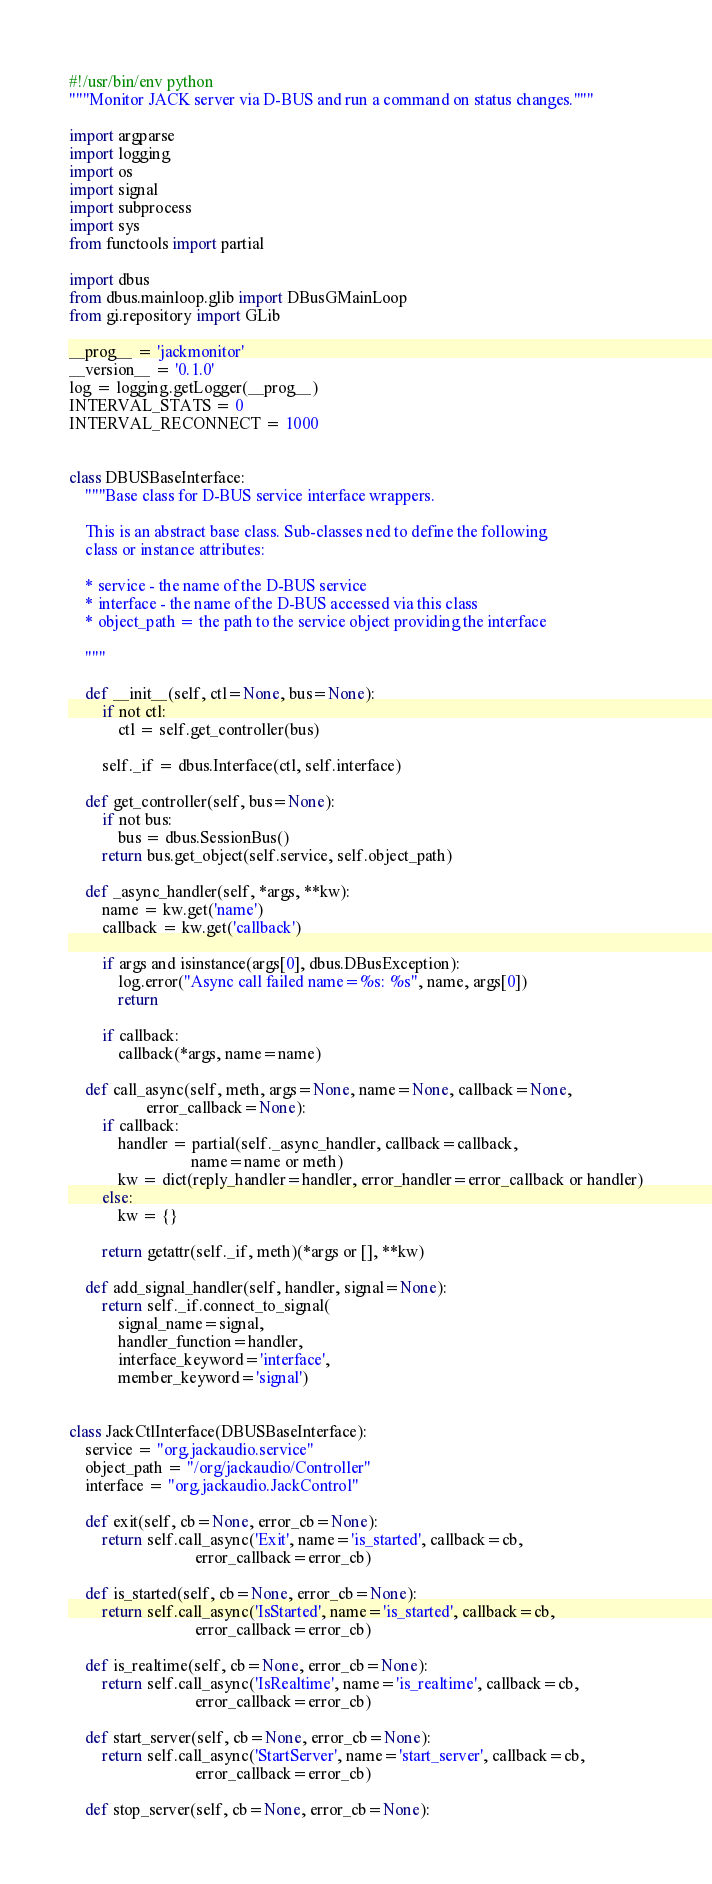<code> <loc_0><loc_0><loc_500><loc_500><_Python_>#!/usr/bin/env python
"""Monitor JACK server via D-BUS and run a command on status changes."""

import argparse
import logging
import os
import signal
import subprocess
import sys
from functools import partial

import dbus
from dbus.mainloop.glib import DBusGMainLoop
from gi.repository import GLib

__prog__ = 'jackmonitor'
__version__ = '0.1.0'
log = logging.getLogger(__prog__)
INTERVAL_STATS = 0
INTERVAL_RECONNECT = 1000


class DBUSBaseInterface:
    """Base class for D-BUS service interface wrappers.

    This is an abstract base class. Sub-classes ned to define the following
    class or instance attributes:

    * service - the name of the D-BUS service
    * interface - the name of the D-BUS accessed via this class
    * object_path = the path to the service object providing the interface

    """

    def __init__(self, ctl=None, bus=None):
        if not ctl:
            ctl = self.get_controller(bus)

        self._if = dbus.Interface(ctl, self.interface)

    def get_controller(self, bus=None):
        if not bus:
            bus = dbus.SessionBus()
        return bus.get_object(self.service, self.object_path)

    def _async_handler(self, *args, **kw):
        name = kw.get('name')
        callback = kw.get('callback')

        if args and isinstance(args[0], dbus.DBusException):
            log.error("Async call failed name=%s: %s", name, args[0])
            return

        if callback:
            callback(*args, name=name)

    def call_async(self, meth, args=None, name=None, callback=None,
                   error_callback=None):
        if callback:
            handler = partial(self._async_handler, callback=callback,
                              name=name or meth)
            kw = dict(reply_handler=handler, error_handler=error_callback or handler)
        else:
            kw = {}

        return getattr(self._if, meth)(*args or [], **kw)

    def add_signal_handler(self, handler, signal=None):
        return self._if.connect_to_signal(
            signal_name=signal,
            handler_function=handler,
            interface_keyword='interface',
            member_keyword='signal')


class JackCtlInterface(DBUSBaseInterface):
    service = "org.jackaudio.service"
    object_path = "/org/jackaudio/Controller"
    interface = "org.jackaudio.JackControl"

    def exit(self, cb=None, error_cb=None):
        return self.call_async('Exit', name='is_started', callback=cb,
                               error_callback=error_cb)

    def is_started(self, cb=None, error_cb=None):
        return self.call_async('IsStarted', name='is_started', callback=cb,
                               error_callback=error_cb)

    def is_realtime(self, cb=None, error_cb=None):
        return self.call_async('IsRealtime', name='is_realtime', callback=cb,
                               error_callback=error_cb)

    def start_server(self, cb=None, error_cb=None):
        return self.call_async('StartServer', name='start_server', callback=cb,
                               error_callback=error_cb)

    def stop_server(self, cb=None, error_cb=None):</code> 